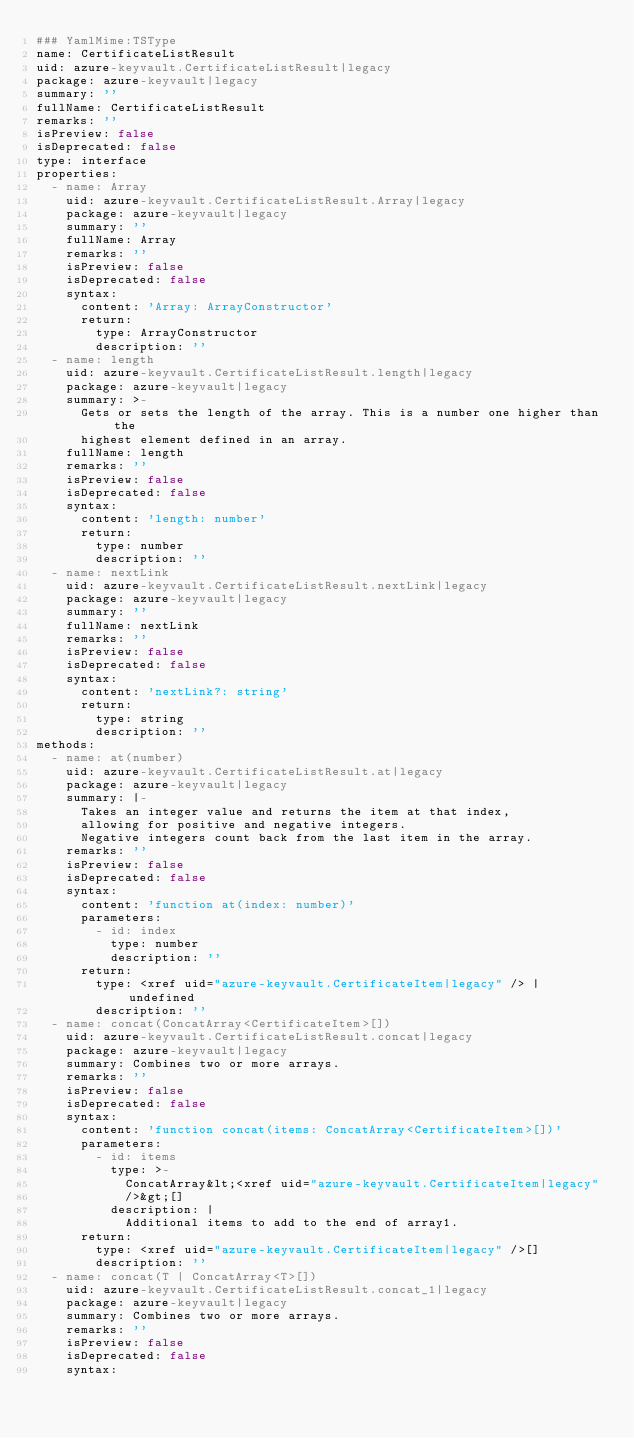Convert code to text. <code><loc_0><loc_0><loc_500><loc_500><_YAML_>### YamlMime:TSType
name: CertificateListResult
uid: azure-keyvault.CertificateListResult|legacy
package: azure-keyvault|legacy
summary: ''
fullName: CertificateListResult
remarks: ''
isPreview: false
isDeprecated: false
type: interface
properties:
  - name: Array
    uid: azure-keyvault.CertificateListResult.Array|legacy
    package: azure-keyvault|legacy
    summary: ''
    fullName: Array
    remarks: ''
    isPreview: false
    isDeprecated: false
    syntax:
      content: 'Array: ArrayConstructor'
      return:
        type: ArrayConstructor
        description: ''
  - name: length
    uid: azure-keyvault.CertificateListResult.length|legacy
    package: azure-keyvault|legacy
    summary: >-
      Gets or sets the length of the array. This is a number one higher than the
      highest element defined in an array.
    fullName: length
    remarks: ''
    isPreview: false
    isDeprecated: false
    syntax:
      content: 'length: number'
      return:
        type: number
        description: ''
  - name: nextLink
    uid: azure-keyvault.CertificateListResult.nextLink|legacy
    package: azure-keyvault|legacy
    summary: ''
    fullName: nextLink
    remarks: ''
    isPreview: false
    isDeprecated: false
    syntax:
      content: 'nextLink?: string'
      return:
        type: string
        description: ''
methods:
  - name: at(number)
    uid: azure-keyvault.CertificateListResult.at|legacy
    package: azure-keyvault|legacy
    summary: |-
      Takes an integer value and returns the item at that index,
      allowing for positive and negative integers.
      Negative integers count back from the last item in the array.
    remarks: ''
    isPreview: false
    isDeprecated: false
    syntax:
      content: 'function at(index: number)'
      parameters:
        - id: index
          type: number
          description: ''
      return:
        type: <xref uid="azure-keyvault.CertificateItem|legacy" /> | undefined
        description: ''
  - name: concat(ConcatArray<CertificateItem>[])
    uid: azure-keyvault.CertificateListResult.concat|legacy
    package: azure-keyvault|legacy
    summary: Combines two or more arrays.
    remarks: ''
    isPreview: false
    isDeprecated: false
    syntax:
      content: 'function concat(items: ConcatArray<CertificateItem>[])'
      parameters:
        - id: items
          type: >-
            ConcatArray&lt;<xref uid="azure-keyvault.CertificateItem|legacy"
            />&gt;[]
          description: |
            Additional items to add to the end of array1.
      return:
        type: <xref uid="azure-keyvault.CertificateItem|legacy" />[]
        description: ''
  - name: concat(T | ConcatArray<T>[])
    uid: azure-keyvault.CertificateListResult.concat_1|legacy
    package: azure-keyvault|legacy
    summary: Combines two or more arrays.
    remarks: ''
    isPreview: false
    isDeprecated: false
    syntax:</code> 